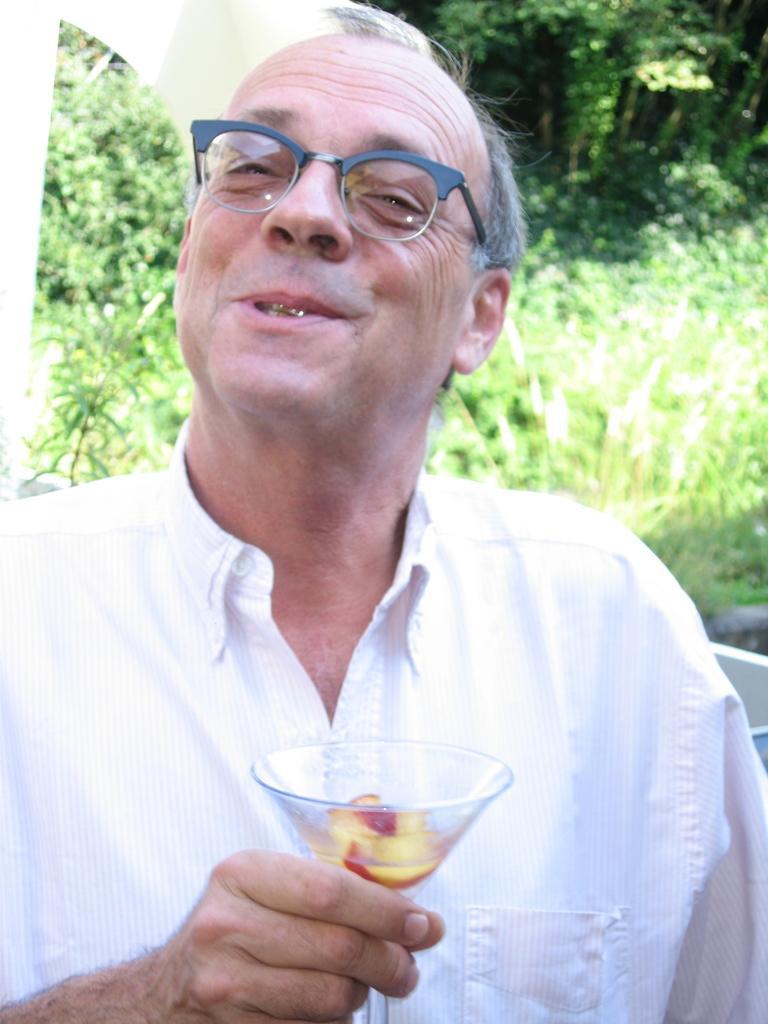Could you give a brief overview of what you see in this image? In this image I can see a person is holding a glass and wearing white color dress. Back I can see few trees. 